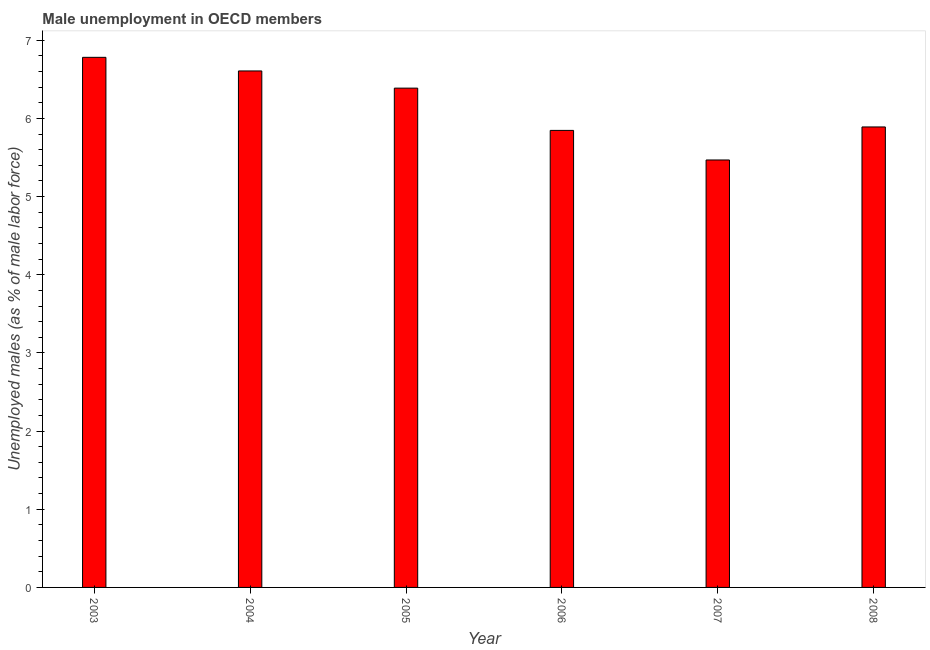Does the graph contain any zero values?
Make the answer very short. No. What is the title of the graph?
Keep it short and to the point. Male unemployment in OECD members. What is the label or title of the X-axis?
Your answer should be very brief. Year. What is the label or title of the Y-axis?
Your answer should be compact. Unemployed males (as % of male labor force). What is the unemployed males population in 2005?
Your response must be concise. 6.39. Across all years, what is the maximum unemployed males population?
Provide a succinct answer. 6.78. Across all years, what is the minimum unemployed males population?
Your answer should be very brief. 5.47. In which year was the unemployed males population maximum?
Your response must be concise. 2003. In which year was the unemployed males population minimum?
Your answer should be compact. 2007. What is the sum of the unemployed males population?
Provide a short and direct response. 36.98. What is the difference between the unemployed males population in 2004 and 2006?
Give a very brief answer. 0.76. What is the average unemployed males population per year?
Ensure brevity in your answer.  6.16. What is the median unemployed males population?
Keep it short and to the point. 6.14. In how many years, is the unemployed males population greater than 4.6 %?
Offer a terse response. 6. What is the ratio of the unemployed males population in 2004 to that in 2006?
Provide a succinct answer. 1.13. What is the difference between the highest and the second highest unemployed males population?
Offer a terse response. 0.17. Is the sum of the unemployed males population in 2003 and 2008 greater than the maximum unemployed males population across all years?
Offer a terse response. Yes. What is the difference between the highest and the lowest unemployed males population?
Make the answer very short. 1.31. Are the values on the major ticks of Y-axis written in scientific E-notation?
Your answer should be compact. No. What is the Unemployed males (as % of male labor force) of 2003?
Your answer should be compact. 6.78. What is the Unemployed males (as % of male labor force) of 2004?
Offer a very short reply. 6.61. What is the Unemployed males (as % of male labor force) of 2005?
Make the answer very short. 6.39. What is the Unemployed males (as % of male labor force) of 2006?
Your answer should be very brief. 5.85. What is the Unemployed males (as % of male labor force) in 2007?
Give a very brief answer. 5.47. What is the Unemployed males (as % of male labor force) of 2008?
Provide a short and direct response. 5.89. What is the difference between the Unemployed males (as % of male labor force) in 2003 and 2004?
Give a very brief answer. 0.17. What is the difference between the Unemployed males (as % of male labor force) in 2003 and 2005?
Offer a very short reply. 0.39. What is the difference between the Unemployed males (as % of male labor force) in 2003 and 2006?
Ensure brevity in your answer.  0.93. What is the difference between the Unemployed males (as % of male labor force) in 2003 and 2007?
Give a very brief answer. 1.31. What is the difference between the Unemployed males (as % of male labor force) in 2003 and 2008?
Offer a terse response. 0.89. What is the difference between the Unemployed males (as % of male labor force) in 2004 and 2005?
Offer a very short reply. 0.22. What is the difference between the Unemployed males (as % of male labor force) in 2004 and 2006?
Give a very brief answer. 0.76. What is the difference between the Unemployed males (as % of male labor force) in 2004 and 2007?
Make the answer very short. 1.14. What is the difference between the Unemployed males (as % of male labor force) in 2004 and 2008?
Give a very brief answer. 0.72. What is the difference between the Unemployed males (as % of male labor force) in 2005 and 2006?
Keep it short and to the point. 0.54. What is the difference between the Unemployed males (as % of male labor force) in 2005 and 2007?
Provide a succinct answer. 0.92. What is the difference between the Unemployed males (as % of male labor force) in 2005 and 2008?
Keep it short and to the point. 0.5. What is the difference between the Unemployed males (as % of male labor force) in 2006 and 2007?
Give a very brief answer. 0.38. What is the difference between the Unemployed males (as % of male labor force) in 2006 and 2008?
Make the answer very short. -0.04. What is the difference between the Unemployed males (as % of male labor force) in 2007 and 2008?
Give a very brief answer. -0.42. What is the ratio of the Unemployed males (as % of male labor force) in 2003 to that in 2005?
Ensure brevity in your answer.  1.06. What is the ratio of the Unemployed males (as % of male labor force) in 2003 to that in 2006?
Ensure brevity in your answer.  1.16. What is the ratio of the Unemployed males (as % of male labor force) in 2003 to that in 2007?
Make the answer very short. 1.24. What is the ratio of the Unemployed males (as % of male labor force) in 2003 to that in 2008?
Your answer should be very brief. 1.15. What is the ratio of the Unemployed males (as % of male labor force) in 2004 to that in 2005?
Provide a succinct answer. 1.03. What is the ratio of the Unemployed males (as % of male labor force) in 2004 to that in 2006?
Give a very brief answer. 1.13. What is the ratio of the Unemployed males (as % of male labor force) in 2004 to that in 2007?
Make the answer very short. 1.21. What is the ratio of the Unemployed males (as % of male labor force) in 2004 to that in 2008?
Offer a very short reply. 1.12. What is the ratio of the Unemployed males (as % of male labor force) in 2005 to that in 2006?
Your response must be concise. 1.09. What is the ratio of the Unemployed males (as % of male labor force) in 2005 to that in 2007?
Give a very brief answer. 1.17. What is the ratio of the Unemployed males (as % of male labor force) in 2005 to that in 2008?
Ensure brevity in your answer.  1.08. What is the ratio of the Unemployed males (as % of male labor force) in 2006 to that in 2007?
Offer a very short reply. 1.07. What is the ratio of the Unemployed males (as % of male labor force) in 2007 to that in 2008?
Make the answer very short. 0.93. 